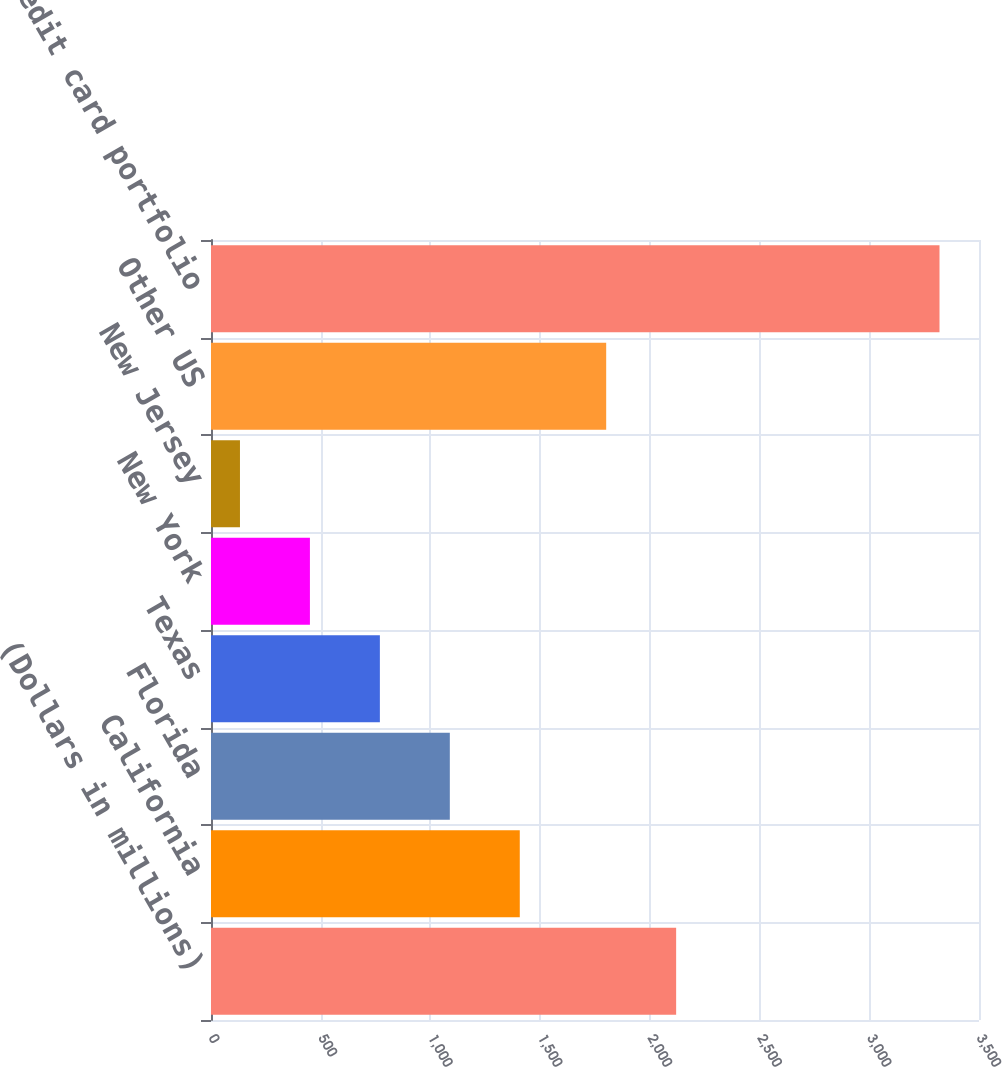<chart> <loc_0><loc_0><loc_500><loc_500><bar_chart><fcel>(Dollars in millions)<fcel>California<fcel>Florida<fcel>Texas<fcel>New York<fcel>New Jersey<fcel>Other US<fcel>Total US credit card portfolio<nl><fcel>2119.8<fcel>1407.2<fcel>1088.4<fcel>769.6<fcel>450.8<fcel>132<fcel>1801<fcel>3320<nl></chart> 